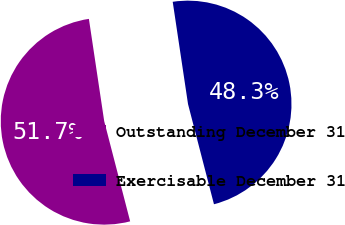<chart> <loc_0><loc_0><loc_500><loc_500><pie_chart><fcel>Outstanding December 31<fcel>Exercisable December 31<nl><fcel>51.67%<fcel>48.33%<nl></chart> 